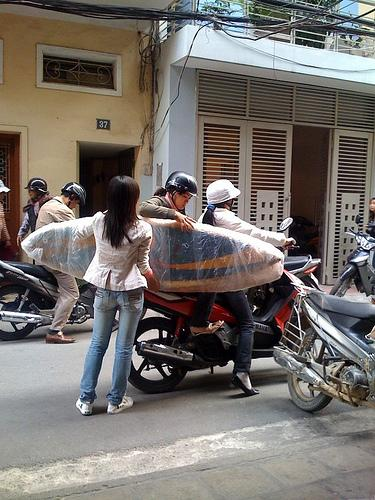What color is the background on the surfboard wrapped up with cello wrap? blue 